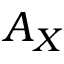Convert formula to latex. <formula><loc_0><loc_0><loc_500><loc_500>A _ { X }</formula> 